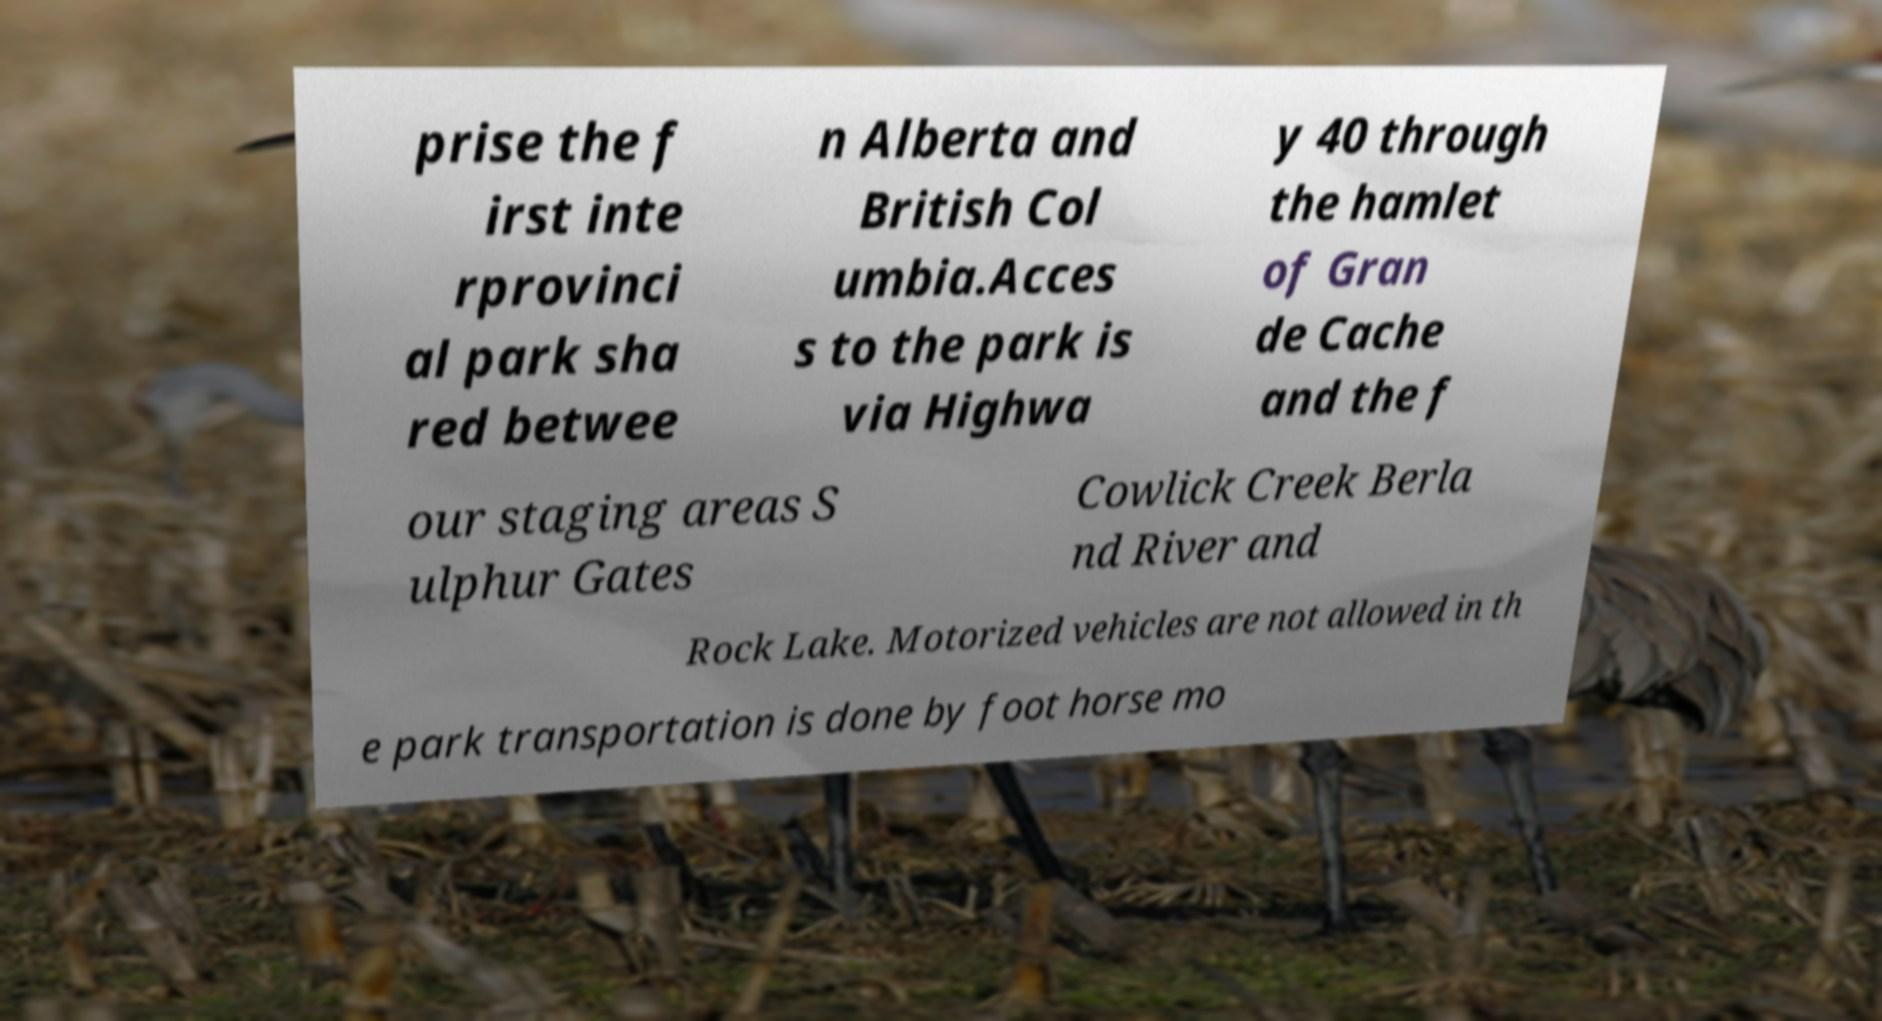Can you accurately transcribe the text from the provided image for me? prise the f irst inte rprovinci al park sha red betwee n Alberta and British Col umbia.Acces s to the park is via Highwa y 40 through the hamlet of Gran de Cache and the f our staging areas S ulphur Gates Cowlick Creek Berla nd River and Rock Lake. Motorized vehicles are not allowed in th e park transportation is done by foot horse mo 